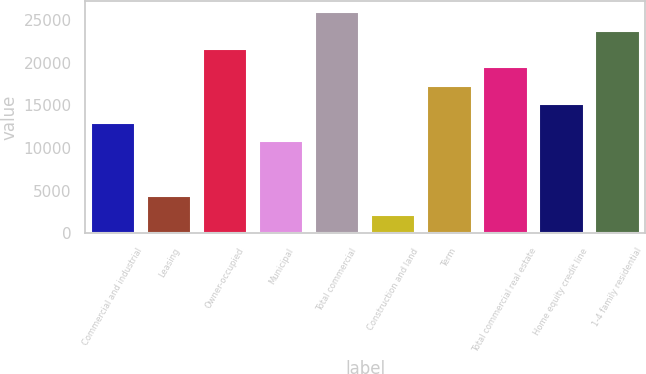<chart> <loc_0><loc_0><loc_500><loc_500><bar_chart><fcel>Commercial and industrial<fcel>Leasing<fcel>Owner-occupied<fcel>Municipal<fcel>Total commercial<fcel>Construction and land<fcel>Term<fcel>Total commercial real estate<fcel>Home equity credit line<fcel>1-4 family residential<nl><fcel>12978.2<fcel>4349.4<fcel>21607<fcel>10821<fcel>25921.4<fcel>2192.2<fcel>17292.6<fcel>19449.8<fcel>15135.4<fcel>23764.2<nl></chart> 